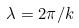<formula> <loc_0><loc_0><loc_500><loc_500>\lambda = 2 \pi / k</formula> 